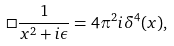Convert formula to latex. <formula><loc_0><loc_0><loc_500><loc_500>\Box \frac { 1 } { x ^ { 2 } + i \epsilon } = 4 \pi ^ { 2 } i \delta ^ { 4 } ( x ) ,</formula> 